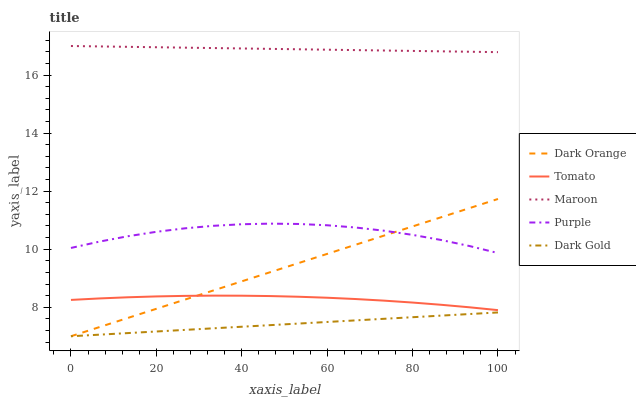Does Dark Gold have the minimum area under the curve?
Answer yes or no. Yes. Does Maroon have the maximum area under the curve?
Answer yes or no. Yes. Does Dark Orange have the minimum area under the curve?
Answer yes or no. No. Does Dark Orange have the maximum area under the curve?
Answer yes or no. No. Is Dark Gold the smoothest?
Answer yes or no. Yes. Is Purple the roughest?
Answer yes or no. Yes. Is Dark Orange the smoothest?
Answer yes or no. No. Is Dark Orange the roughest?
Answer yes or no. No. Does Purple have the lowest value?
Answer yes or no. No. Does Dark Orange have the highest value?
Answer yes or no. No. Is Dark Gold less than Maroon?
Answer yes or no. Yes. Is Maroon greater than Tomato?
Answer yes or no. Yes. Does Dark Gold intersect Maroon?
Answer yes or no. No. 